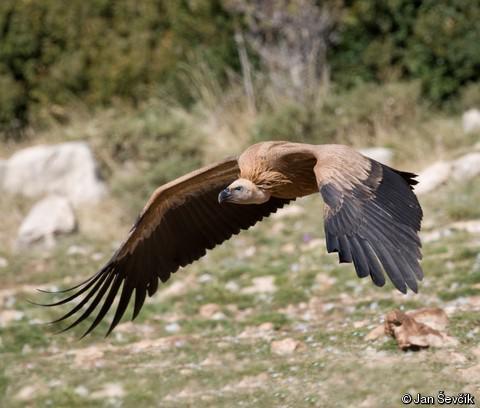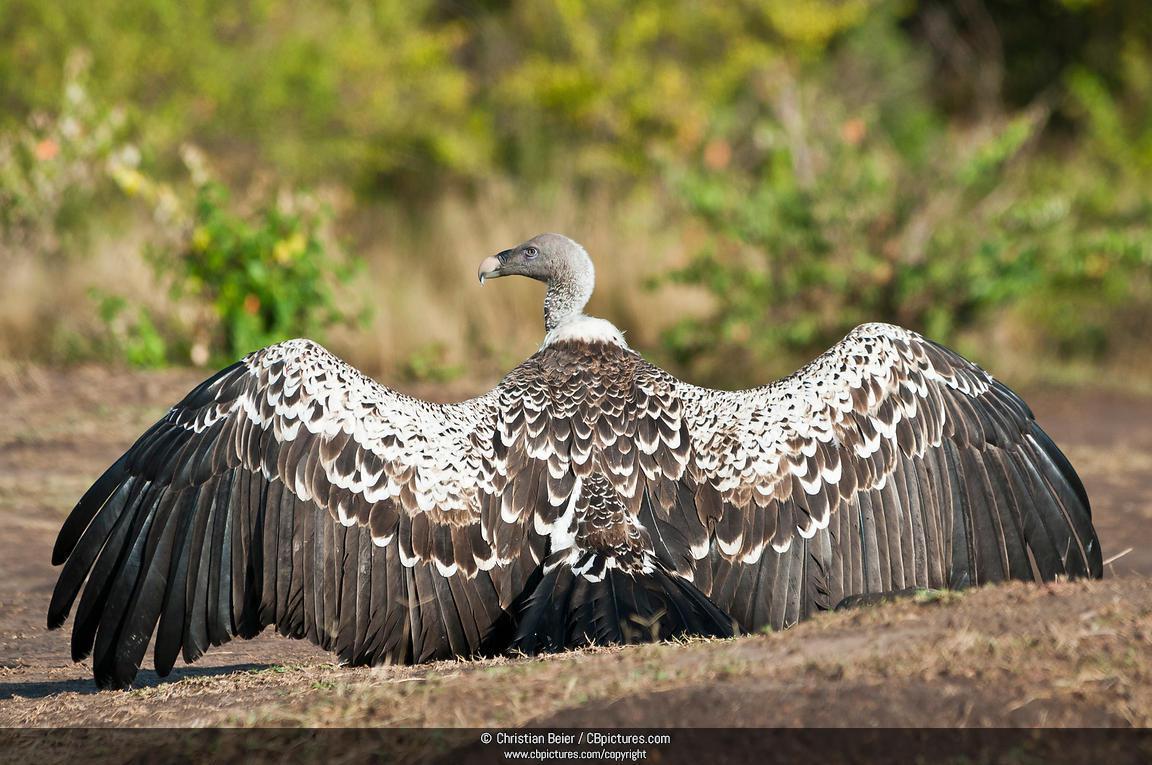The first image is the image on the left, the second image is the image on the right. Given the left and right images, does the statement "The left and right image contains the same number of vaulters" hold true? Answer yes or no. Yes. The first image is the image on the left, the second image is the image on the right. Assess this claim about the two images: "In all images at least one bird has its wings open, and in one image that bird is on the ground and in the other it is in the air.". Correct or not? Answer yes or no. Yes. 